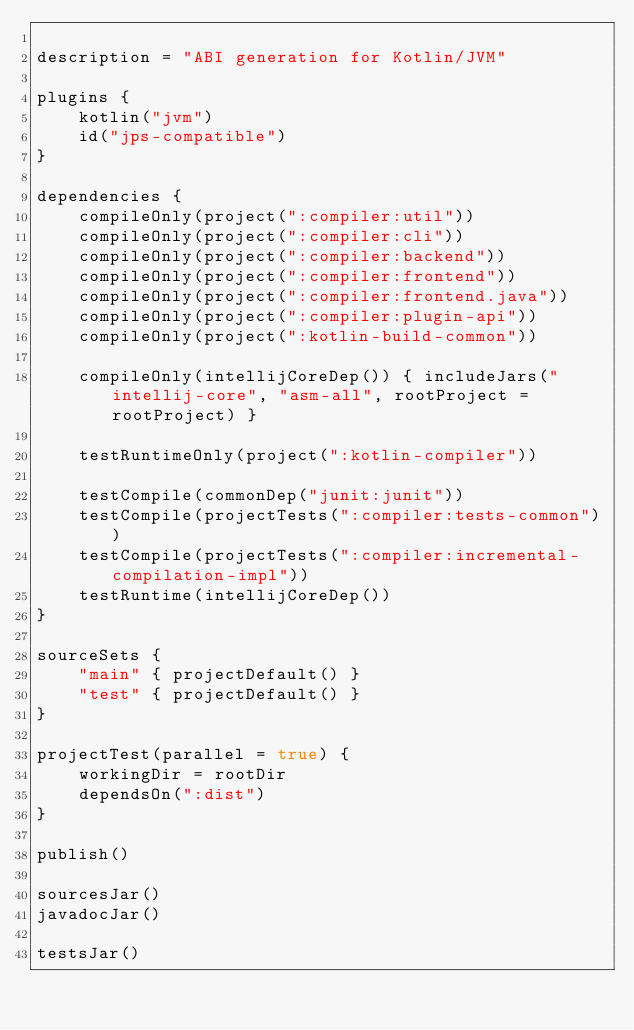Convert code to text. <code><loc_0><loc_0><loc_500><loc_500><_Kotlin_>
description = "ABI generation for Kotlin/JVM"

plugins {
    kotlin("jvm")
    id("jps-compatible")
}

dependencies {
    compileOnly(project(":compiler:util"))
    compileOnly(project(":compiler:cli"))
    compileOnly(project(":compiler:backend"))
    compileOnly(project(":compiler:frontend"))
    compileOnly(project(":compiler:frontend.java"))
    compileOnly(project(":compiler:plugin-api"))
    compileOnly(project(":kotlin-build-common"))

    compileOnly(intellijCoreDep()) { includeJars("intellij-core", "asm-all", rootProject = rootProject) }

    testRuntimeOnly(project(":kotlin-compiler"))

    testCompile(commonDep("junit:junit"))
    testCompile(projectTests(":compiler:tests-common"))
    testCompile(projectTests(":compiler:incremental-compilation-impl"))
    testRuntime(intellijCoreDep())
}

sourceSets {
    "main" { projectDefault() }
    "test" { projectDefault() }
}

projectTest(parallel = true) {
    workingDir = rootDir
    dependsOn(":dist")
}

publish()

sourcesJar()
javadocJar()

testsJar()</code> 